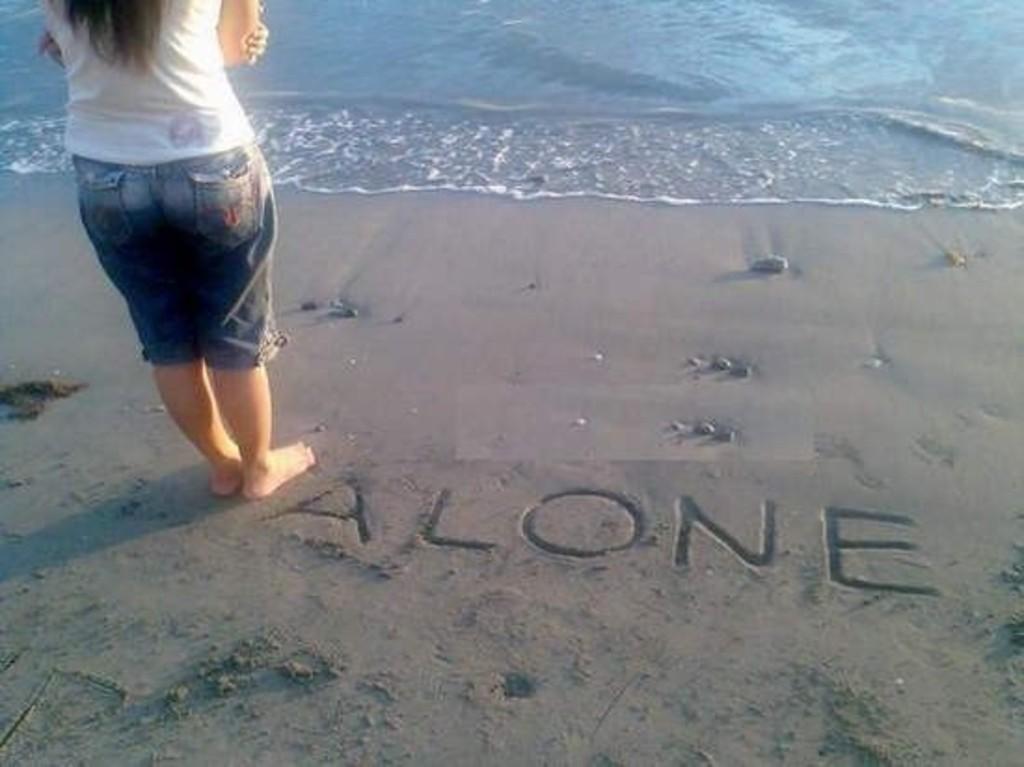Describe this image in one or two sentences. In this image there is a woman standing on the shore. In front of her there is water. There is text written on the shore. 